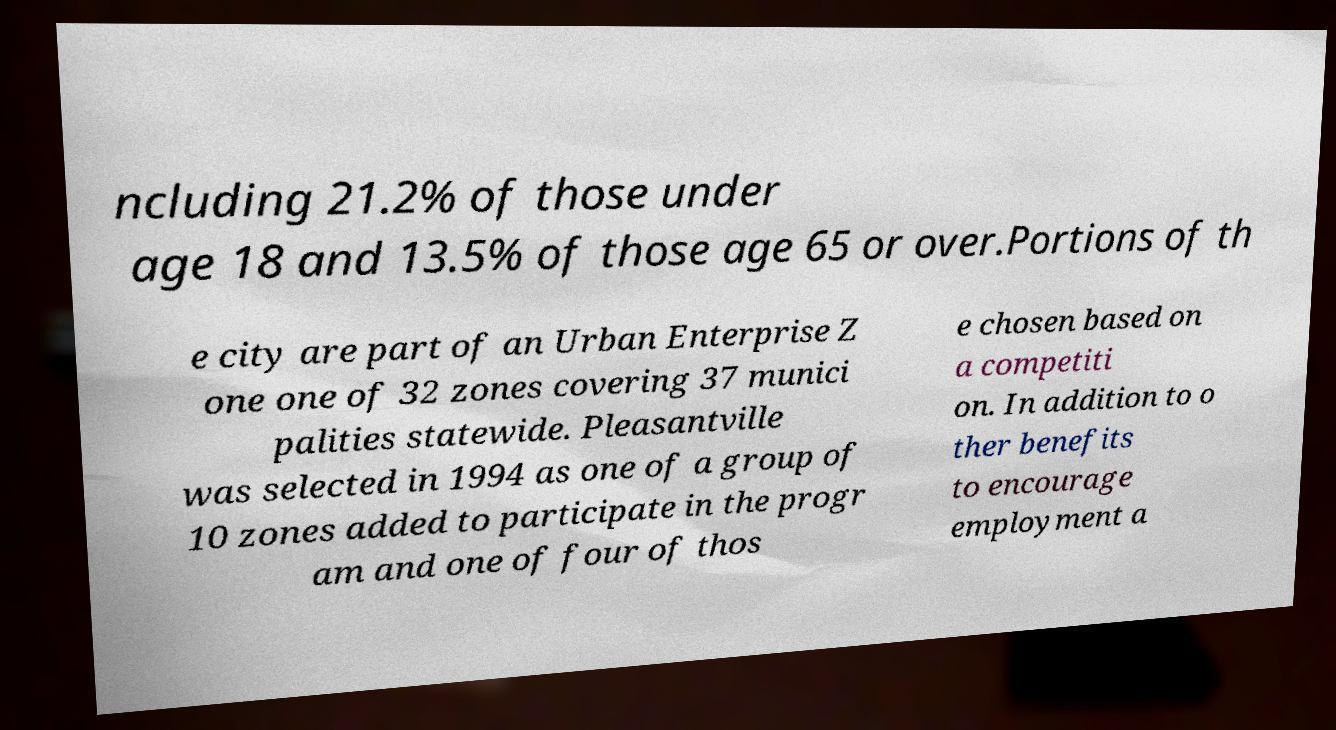Could you assist in decoding the text presented in this image and type it out clearly? ncluding 21.2% of those under age 18 and 13.5% of those age 65 or over.Portions of th e city are part of an Urban Enterprise Z one one of 32 zones covering 37 munici palities statewide. Pleasantville was selected in 1994 as one of a group of 10 zones added to participate in the progr am and one of four of thos e chosen based on a competiti on. In addition to o ther benefits to encourage employment a 